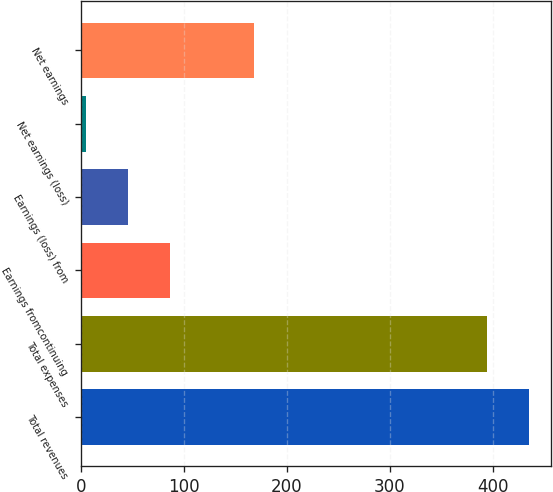Convert chart to OTSL. <chart><loc_0><loc_0><loc_500><loc_500><bar_chart><fcel>Total revenues<fcel>Total expenses<fcel>Earnings fromcontinuing<fcel>Earnings (loss) from<fcel>Net earnings (loss)<fcel>Net earnings<nl><fcel>434.84<fcel>394.1<fcel>86.18<fcel>45.44<fcel>4.7<fcel>167.66<nl></chart> 